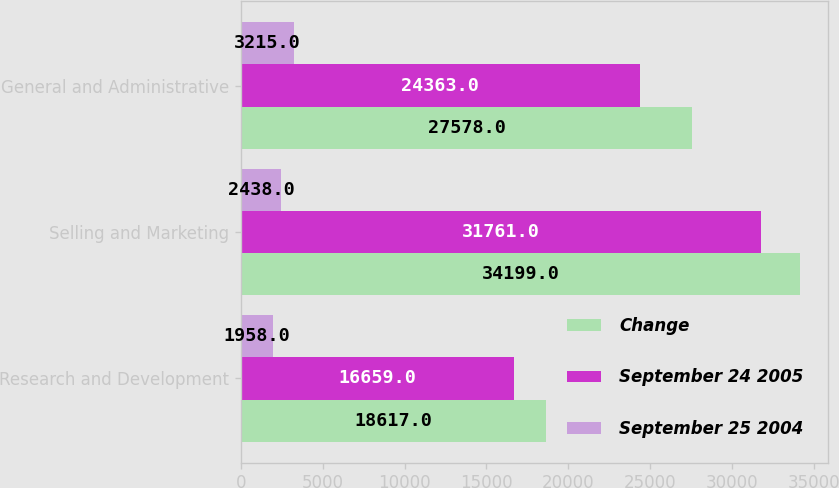Convert chart to OTSL. <chart><loc_0><loc_0><loc_500><loc_500><stacked_bar_chart><ecel><fcel>Research and Development<fcel>Selling and Marketing<fcel>General and Administrative<nl><fcel>Change<fcel>18617<fcel>34199<fcel>27578<nl><fcel>September 24 2005<fcel>16659<fcel>31761<fcel>24363<nl><fcel>September 25 2004<fcel>1958<fcel>2438<fcel>3215<nl></chart> 